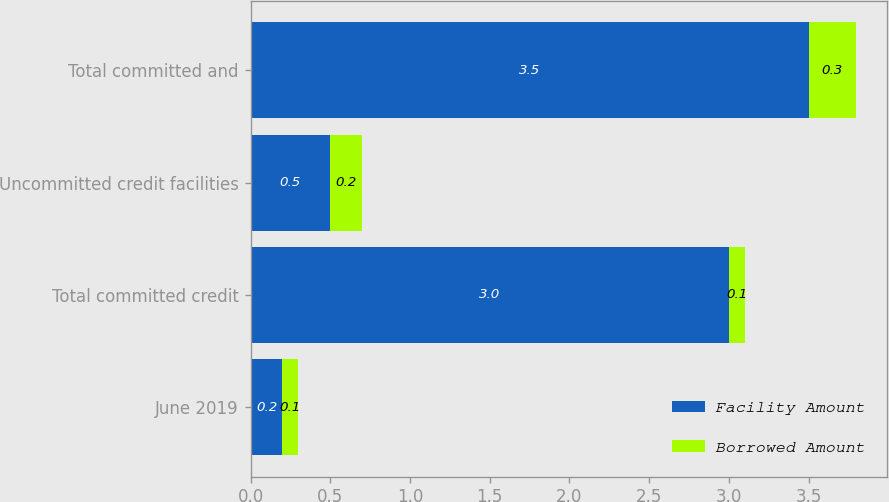Convert chart. <chart><loc_0><loc_0><loc_500><loc_500><stacked_bar_chart><ecel><fcel>June 2019<fcel>Total committed credit<fcel>Uncommitted credit facilities<fcel>Total committed and<nl><fcel>Facility Amount<fcel>0.2<fcel>3<fcel>0.5<fcel>3.5<nl><fcel>Borrowed Amount<fcel>0.1<fcel>0.1<fcel>0.2<fcel>0.3<nl></chart> 